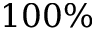Convert formula to latex. <formula><loc_0><loc_0><loc_500><loc_500>1 0 0 \%</formula> 